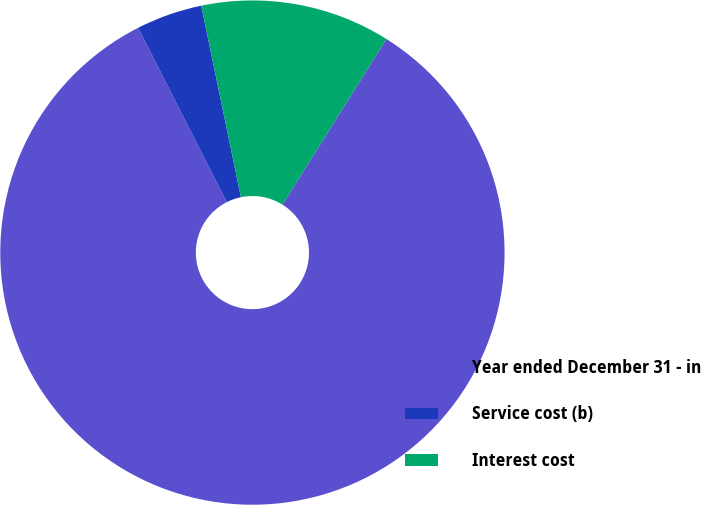Convert chart. <chart><loc_0><loc_0><loc_500><loc_500><pie_chart><fcel>Year ended December 31 - in<fcel>Service cost (b)<fcel>Interest cost<nl><fcel>83.6%<fcel>4.23%<fcel>12.17%<nl></chart> 